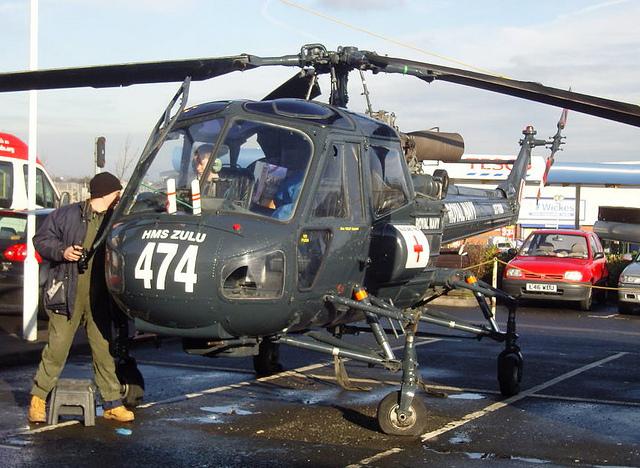What kind of work is this helicopter used for?
Be succinct. Medical. What is the number painted on the helicopter?
Give a very brief answer. 474. What color is the car behind the helicopter?
Write a very short answer. Red. 